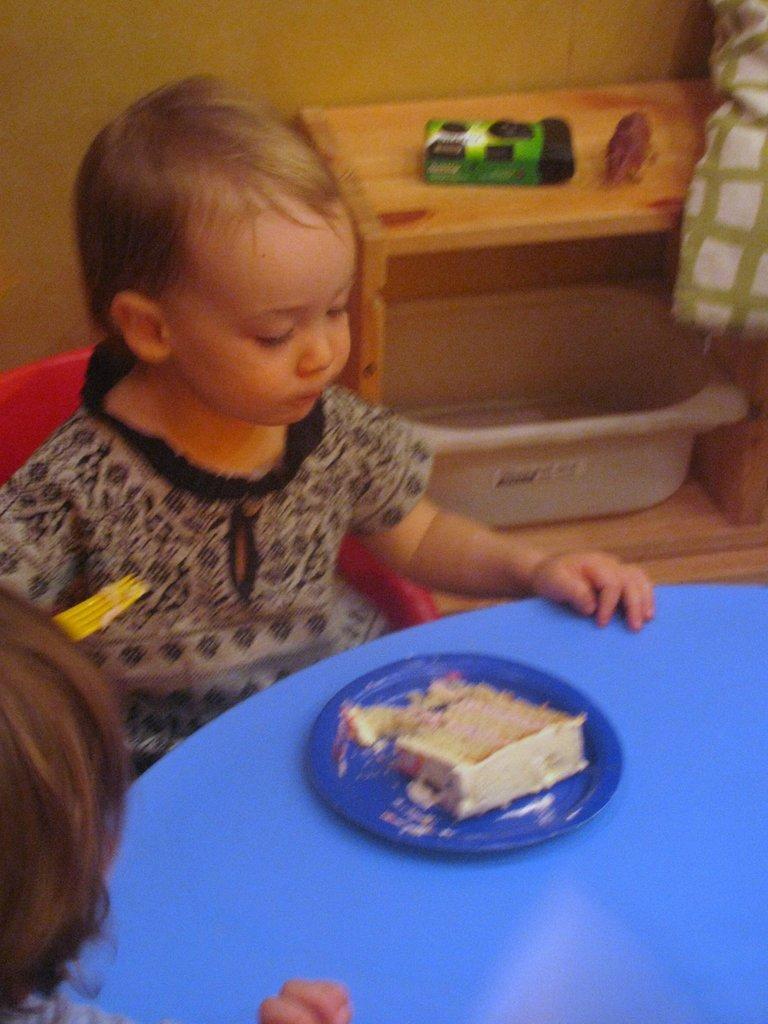In one or two sentences, can you explain what this image depicts? In the image there is a girl sitting in front of the table and there is some food served on the plate in front of her, behind a girl there is a table and there are two objects kept on the table and there is a tub under the table. 